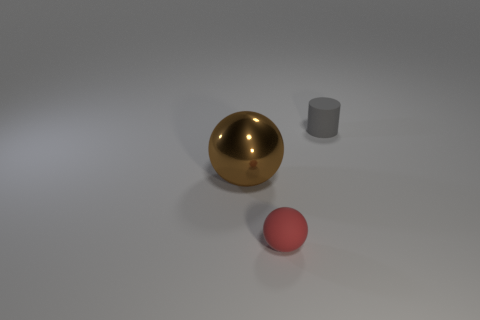Subtract all brown spheres. How many spheres are left? 1 Subtract all spheres. How many objects are left? 1 Add 2 shiny objects. How many objects exist? 5 Subtract 1 spheres. How many spheres are left? 1 Add 1 big brown spheres. How many big brown spheres are left? 2 Add 1 big red shiny cubes. How many big red shiny cubes exist? 1 Subtract 0 cyan cylinders. How many objects are left? 3 Subtract all yellow cylinders. Subtract all red blocks. How many cylinders are left? 1 Subtract all yellow balls. How many brown cylinders are left? 0 Subtract all cylinders. Subtract all metallic spheres. How many objects are left? 1 